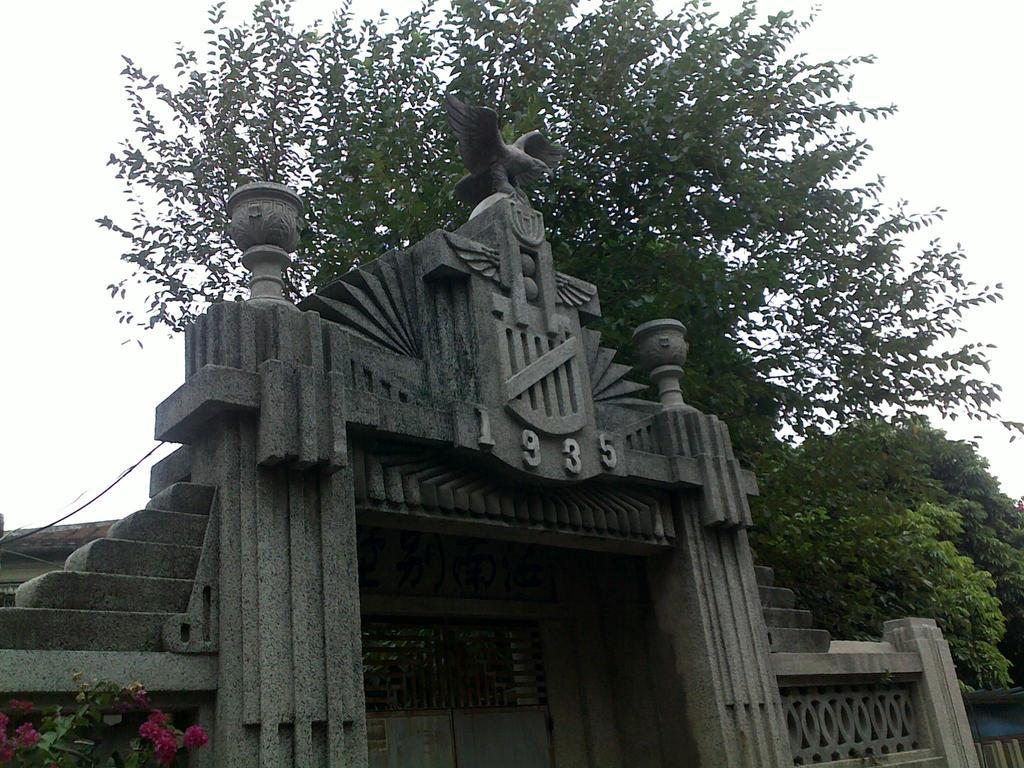<image>
Give a short and clear explanation of the subsequent image. A building with the year numbers 1935 on it. 